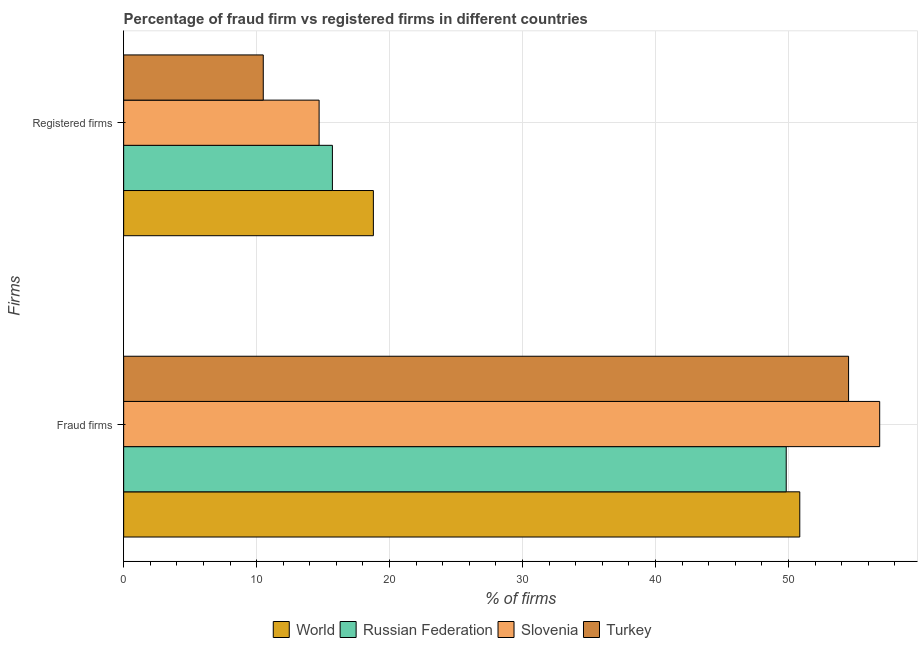How many groups of bars are there?
Offer a very short reply. 2. What is the label of the 1st group of bars from the top?
Keep it short and to the point. Registered firms. What is the percentage of registered firms in Turkey?
Offer a terse response. 10.5. Across all countries, what is the maximum percentage of registered firms?
Your answer should be compact. 18.78. In which country was the percentage of fraud firms maximum?
Offer a very short reply. Slovenia. In which country was the percentage of fraud firms minimum?
Keep it short and to the point. Russian Federation. What is the total percentage of fraud firms in the graph?
Make the answer very short. 212.06. What is the difference between the percentage of registered firms in Turkey and that in Slovenia?
Your answer should be very brief. -4.2. What is the difference between the percentage of fraud firms in Slovenia and the percentage of registered firms in Russian Federation?
Keep it short and to the point. 41.16. What is the average percentage of fraud firms per country?
Your response must be concise. 53.02. What is the difference between the percentage of registered firms and percentage of fraud firms in Slovenia?
Provide a short and direct response. -42.16. In how many countries, is the percentage of registered firms greater than 18 %?
Your response must be concise. 1. What is the ratio of the percentage of registered firms in World to that in Russian Federation?
Your answer should be very brief. 1.2. What does the 3rd bar from the top in Fraud firms represents?
Ensure brevity in your answer.  Russian Federation. How many bars are there?
Offer a very short reply. 8. What is the difference between two consecutive major ticks on the X-axis?
Keep it short and to the point. 10. Where does the legend appear in the graph?
Your response must be concise. Bottom center. How many legend labels are there?
Offer a very short reply. 4. What is the title of the graph?
Your answer should be compact. Percentage of fraud firm vs registered firms in different countries. Does "Northern Mariana Islands" appear as one of the legend labels in the graph?
Ensure brevity in your answer.  No. What is the label or title of the X-axis?
Ensure brevity in your answer.  % of firms. What is the label or title of the Y-axis?
Offer a very short reply. Firms. What is the % of firms of World in Fraud firms?
Make the answer very short. 50.85. What is the % of firms of Russian Federation in Fraud firms?
Your response must be concise. 49.83. What is the % of firms in Slovenia in Fraud firms?
Your answer should be very brief. 56.86. What is the % of firms of Turkey in Fraud firms?
Offer a very short reply. 54.52. What is the % of firms of World in Registered firms?
Your answer should be very brief. 18.78. What is the % of firms in Russian Federation in Registered firms?
Offer a terse response. 15.7. What is the % of firms of Slovenia in Registered firms?
Give a very brief answer. 14.7. Across all Firms, what is the maximum % of firms in World?
Offer a very short reply. 50.85. Across all Firms, what is the maximum % of firms of Russian Federation?
Offer a very short reply. 49.83. Across all Firms, what is the maximum % of firms in Slovenia?
Give a very brief answer. 56.86. Across all Firms, what is the maximum % of firms in Turkey?
Your answer should be very brief. 54.52. Across all Firms, what is the minimum % of firms of World?
Offer a terse response. 18.78. Across all Firms, what is the minimum % of firms in Slovenia?
Offer a very short reply. 14.7. What is the total % of firms of World in the graph?
Offer a terse response. 69.63. What is the total % of firms in Russian Federation in the graph?
Provide a succinct answer. 65.53. What is the total % of firms in Slovenia in the graph?
Offer a very short reply. 71.56. What is the total % of firms of Turkey in the graph?
Your response must be concise. 65.02. What is the difference between the % of firms in World in Fraud firms and that in Registered firms?
Your answer should be compact. 32.07. What is the difference between the % of firms of Russian Federation in Fraud firms and that in Registered firms?
Keep it short and to the point. 34.13. What is the difference between the % of firms of Slovenia in Fraud firms and that in Registered firms?
Give a very brief answer. 42.16. What is the difference between the % of firms of Turkey in Fraud firms and that in Registered firms?
Make the answer very short. 44.02. What is the difference between the % of firms in World in Fraud firms and the % of firms in Russian Federation in Registered firms?
Your answer should be compact. 35.15. What is the difference between the % of firms in World in Fraud firms and the % of firms in Slovenia in Registered firms?
Keep it short and to the point. 36.15. What is the difference between the % of firms of World in Fraud firms and the % of firms of Turkey in Registered firms?
Your answer should be compact. 40.35. What is the difference between the % of firms in Russian Federation in Fraud firms and the % of firms in Slovenia in Registered firms?
Offer a terse response. 35.13. What is the difference between the % of firms in Russian Federation in Fraud firms and the % of firms in Turkey in Registered firms?
Your answer should be very brief. 39.33. What is the difference between the % of firms in Slovenia in Fraud firms and the % of firms in Turkey in Registered firms?
Your answer should be compact. 46.36. What is the average % of firms in World per Firms?
Your answer should be very brief. 34.82. What is the average % of firms in Russian Federation per Firms?
Your answer should be compact. 32.77. What is the average % of firms of Slovenia per Firms?
Offer a terse response. 35.78. What is the average % of firms in Turkey per Firms?
Ensure brevity in your answer.  32.51. What is the difference between the % of firms in World and % of firms in Russian Federation in Fraud firms?
Keep it short and to the point. 1.02. What is the difference between the % of firms in World and % of firms in Slovenia in Fraud firms?
Ensure brevity in your answer.  -6.01. What is the difference between the % of firms in World and % of firms in Turkey in Fraud firms?
Offer a terse response. -3.67. What is the difference between the % of firms in Russian Federation and % of firms in Slovenia in Fraud firms?
Give a very brief answer. -7.03. What is the difference between the % of firms in Russian Federation and % of firms in Turkey in Fraud firms?
Give a very brief answer. -4.69. What is the difference between the % of firms in Slovenia and % of firms in Turkey in Fraud firms?
Offer a very short reply. 2.34. What is the difference between the % of firms in World and % of firms in Russian Federation in Registered firms?
Ensure brevity in your answer.  3.08. What is the difference between the % of firms of World and % of firms of Slovenia in Registered firms?
Ensure brevity in your answer.  4.08. What is the difference between the % of firms in World and % of firms in Turkey in Registered firms?
Make the answer very short. 8.28. What is the difference between the % of firms of Russian Federation and % of firms of Slovenia in Registered firms?
Provide a short and direct response. 1. What is the difference between the % of firms of Russian Federation and % of firms of Turkey in Registered firms?
Provide a succinct answer. 5.2. What is the difference between the % of firms in Slovenia and % of firms in Turkey in Registered firms?
Your answer should be compact. 4.2. What is the ratio of the % of firms of World in Fraud firms to that in Registered firms?
Keep it short and to the point. 2.71. What is the ratio of the % of firms of Russian Federation in Fraud firms to that in Registered firms?
Give a very brief answer. 3.17. What is the ratio of the % of firms of Slovenia in Fraud firms to that in Registered firms?
Offer a very short reply. 3.87. What is the ratio of the % of firms of Turkey in Fraud firms to that in Registered firms?
Offer a very short reply. 5.19. What is the difference between the highest and the second highest % of firms in World?
Offer a very short reply. 32.07. What is the difference between the highest and the second highest % of firms in Russian Federation?
Your answer should be very brief. 34.13. What is the difference between the highest and the second highest % of firms of Slovenia?
Give a very brief answer. 42.16. What is the difference between the highest and the second highest % of firms in Turkey?
Give a very brief answer. 44.02. What is the difference between the highest and the lowest % of firms in World?
Make the answer very short. 32.07. What is the difference between the highest and the lowest % of firms of Russian Federation?
Offer a terse response. 34.13. What is the difference between the highest and the lowest % of firms in Slovenia?
Make the answer very short. 42.16. What is the difference between the highest and the lowest % of firms of Turkey?
Your answer should be compact. 44.02. 